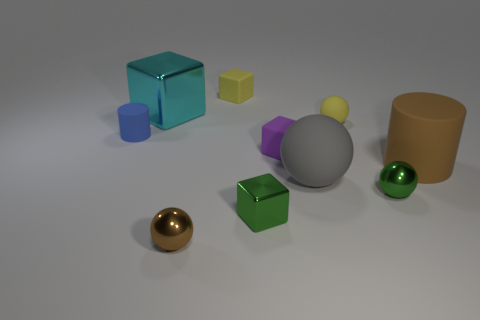Subtract all tiny green blocks. How many blocks are left? 3 Subtract all brown spheres. How many spheres are left? 3 Subtract 1 balls. How many balls are left? 3 Subtract all gray cubes. Subtract all green spheres. How many cubes are left? 4 Subtract all spheres. How many objects are left? 6 Subtract all tiny brown things. Subtract all large brown things. How many objects are left? 8 Add 9 yellow balls. How many yellow balls are left? 10 Add 2 purple matte things. How many purple matte things exist? 3 Subtract 1 purple blocks. How many objects are left? 9 